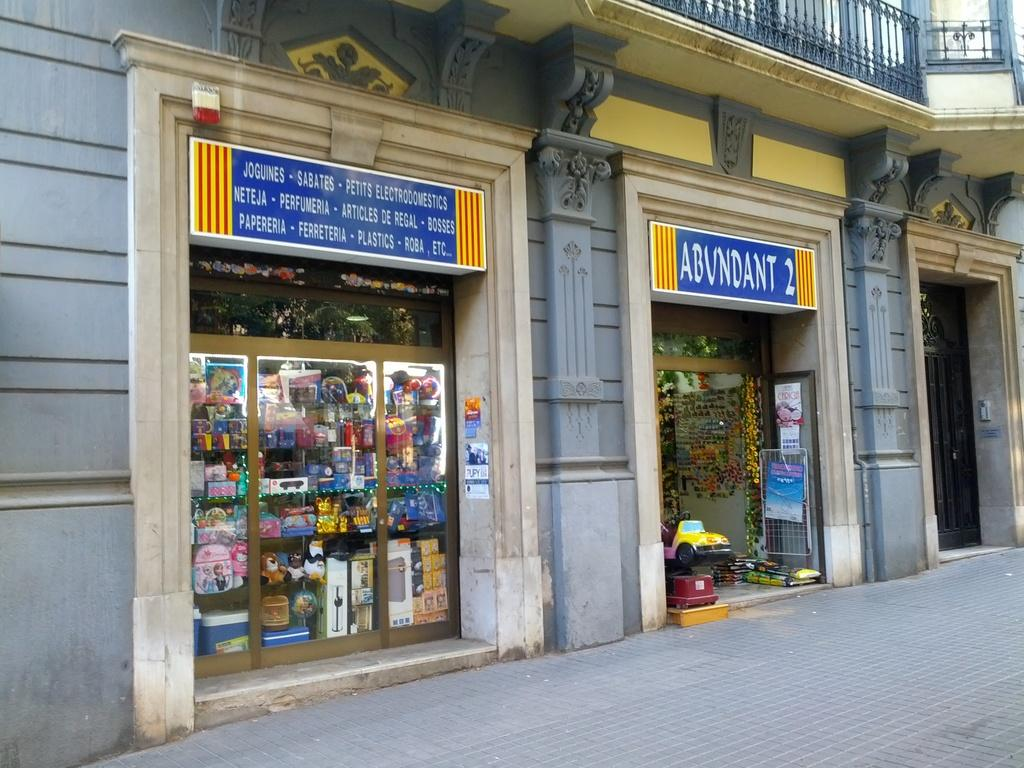Provide a one-sentence caption for the provided image. Outside of a foreign store that sells joguines, sabates, plastics-roba and other items. 